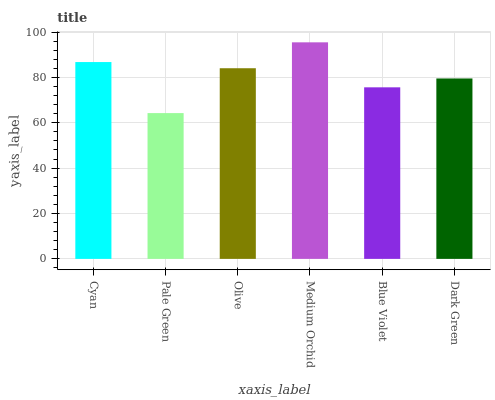Is Pale Green the minimum?
Answer yes or no. Yes. Is Medium Orchid the maximum?
Answer yes or no. Yes. Is Olive the minimum?
Answer yes or no. No. Is Olive the maximum?
Answer yes or no. No. Is Olive greater than Pale Green?
Answer yes or no. Yes. Is Pale Green less than Olive?
Answer yes or no. Yes. Is Pale Green greater than Olive?
Answer yes or no. No. Is Olive less than Pale Green?
Answer yes or no. No. Is Olive the high median?
Answer yes or no. Yes. Is Dark Green the low median?
Answer yes or no. Yes. Is Blue Violet the high median?
Answer yes or no. No. Is Pale Green the low median?
Answer yes or no. No. 